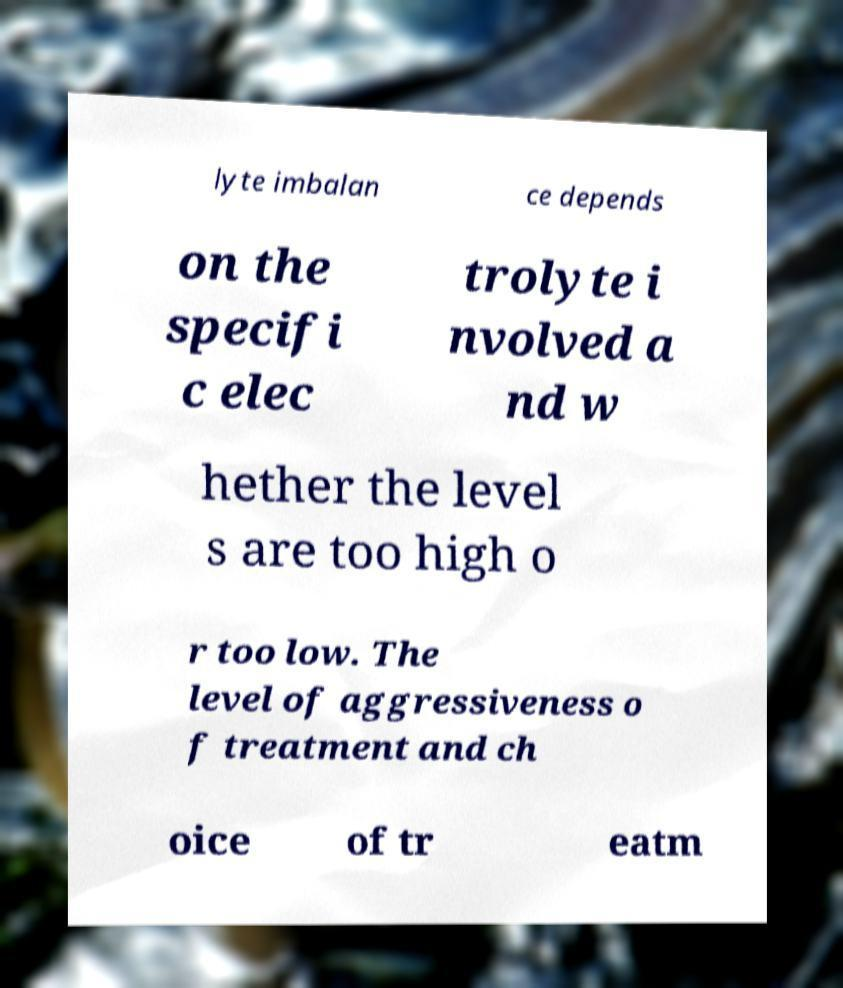Please read and relay the text visible in this image. What does it say? lyte imbalan ce depends on the specifi c elec trolyte i nvolved a nd w hether the level s are too high o r too low. The level of aggressiveness o f treatment and ch oice of tr eatm 